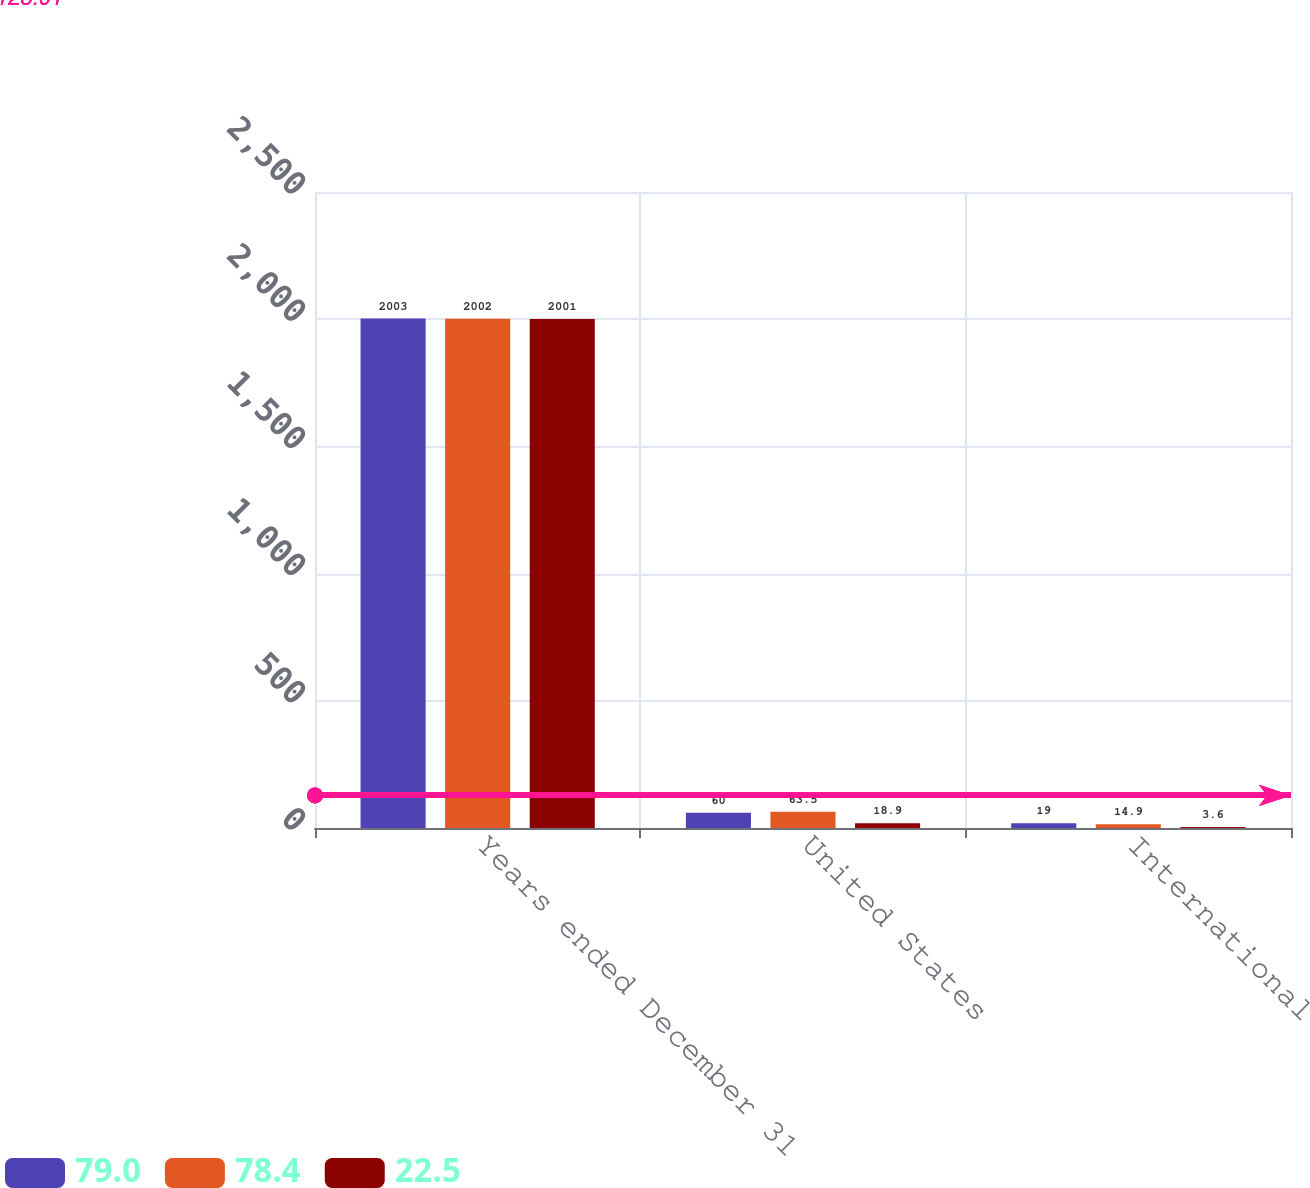Convert chart. <chart><loc_0><loc_0><loc_500><loc_500><stacked_bar_chart><ecel><fcel>Years ended December 31<fcel>United States<fcel>International<nl><fcel>79<fcel>2003<fcel>60<fcel>19<nl><fcel>78.4<fcel>2002<fcel>63.5<fcel>14.9<nl><fcel>22.5<fcel>2001<fcel>18.9<fcel>3.6<nl></chart> 